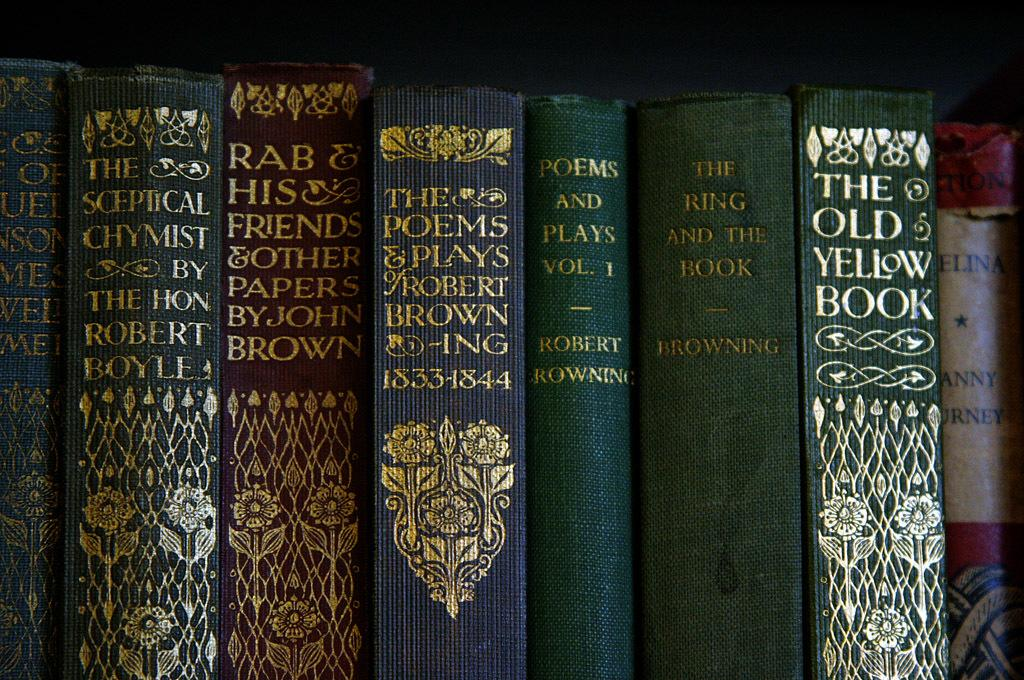<image>
Summarize the visual content of the image. Some books on the shelf and most of them are written by Robert Browning. 